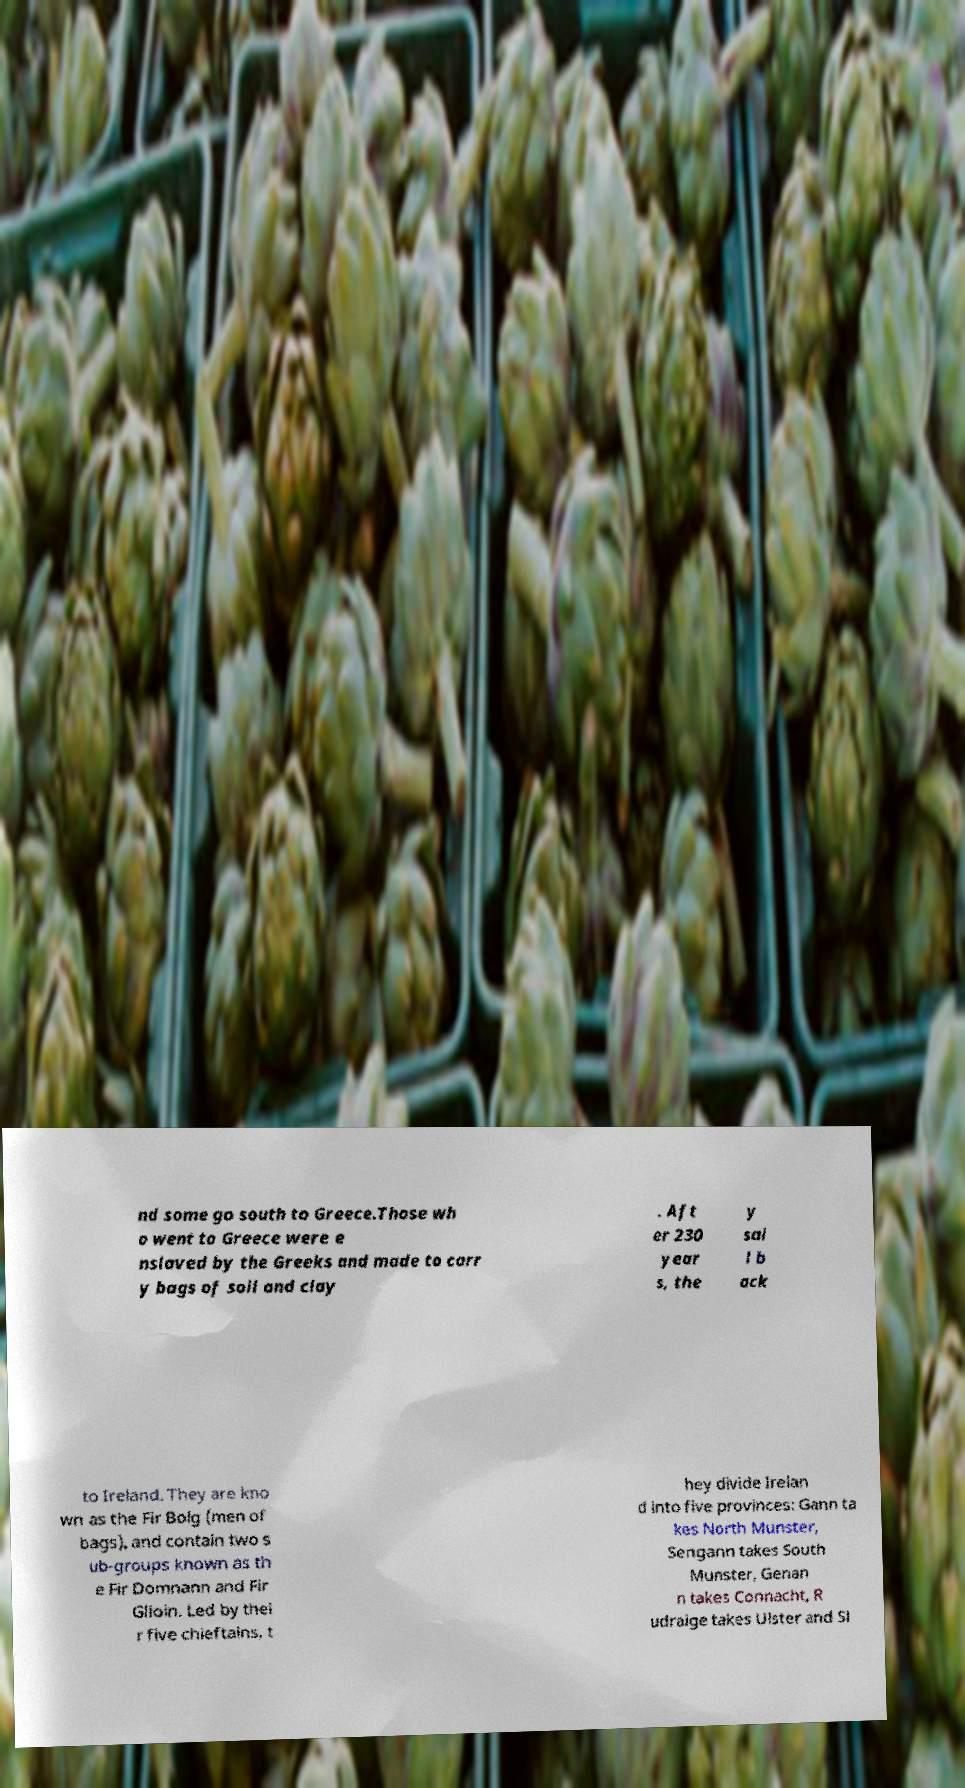Please identify and transcribe the text found in this image. nd some go south to Greece.Those wh o went to Greece were e nslaved by the Greeks and made to carr y bags of soil and clay . Aft er 230 year s, the y sai l b ack to Ireland. They are kno wn as the Fir Bolg (men of bags), and contain two s ub-groups known as th e Fir Domnann and Fir Glioin. Led by thei r five chieftains, t hey divide Irelan d into five provinces: Gann ta kes North Munster, Sengann takes South Munster, Genan n takes Connacht, R udraige takes Ulster and Sl 